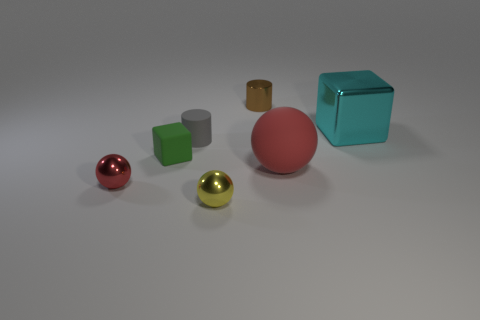What materials are the objects in the image made of? The objects in the image exhibit different textures and sheens, suggesting a variety of materials. For instance, the reflective quality of some spheres indicates they might be metallic, whereas the cube and cylinders have a more matte finish, implying they could be made of plastic or another non-reflective material. 